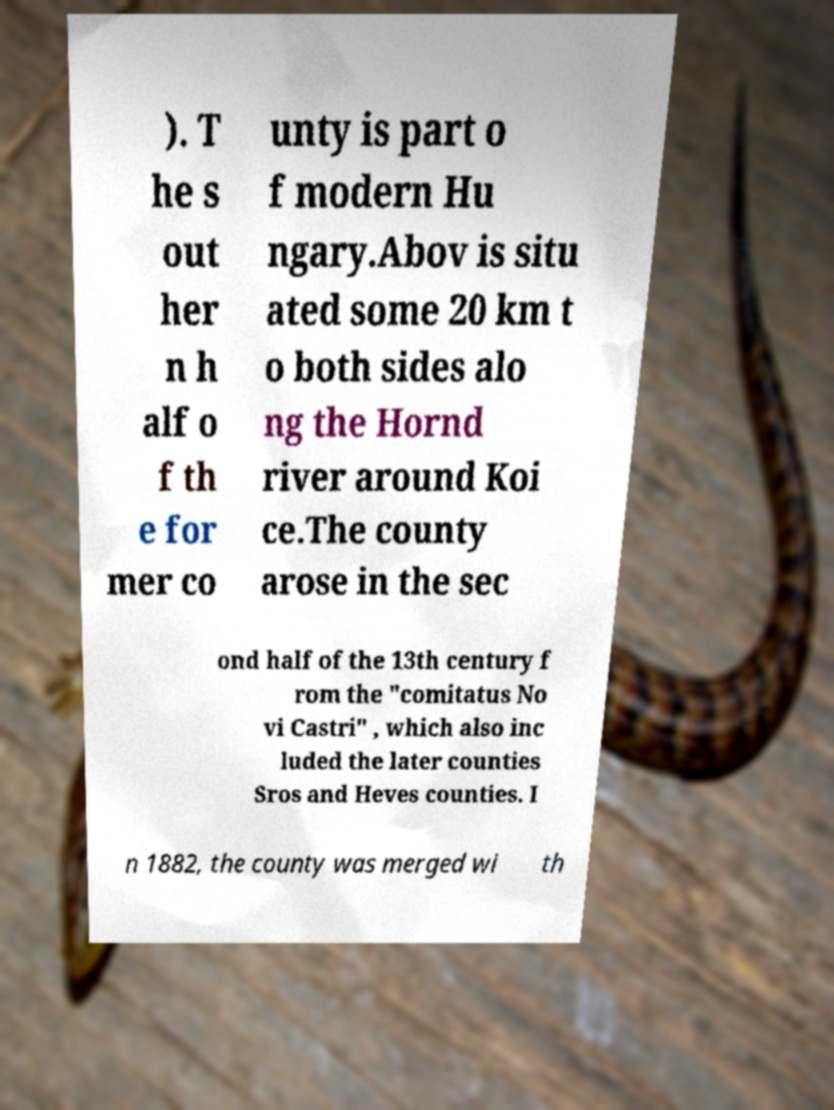Could you assist in decoding the text presented in this image and type it out clearly? ). T he s out her n h alf o f th e for mer co unty is part o f modern Hu ngary.Abov is situ ated some 20 km t o both sides alo ng the Hornd river around Koi ce.The county arose in the sec ond half of the 13th century f rom the "comitatus No vi Castri" , which also inc luded the later counties Sros and Heves counties. I n 1882, the county was merged wi th 